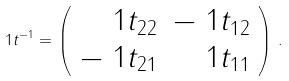<formula> <loc_0><loc_0><loc_500><loc_500>\ 1 t ^ { - 1 } = \left ( \begin{array} { r r } \ 1 t _ { 2 2 } & - \ 1 t _ { 1 2 } \\ - \ 1 t _ { 2 1 } & \ 1 t _ { 1 1 } \end{array} \right ) \, .</formula> 